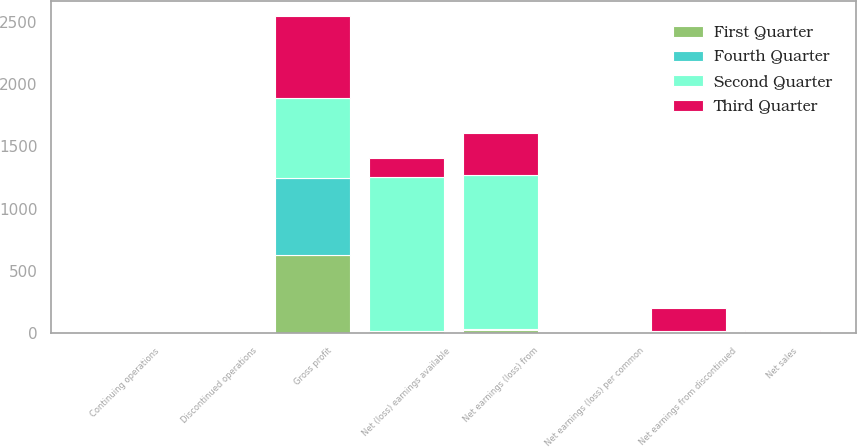Convert chart. <chart><loc_0><loc_0><loc_500><loc_500><stacked_bar_chart><ecel><fcel>Net sales<fcel>Gross profit<fcel>Net earnings (loss) from<fcel>Net earnings from discontinued<fcel>Net (loss) earnings available<fcel>Continuing operations<fcel>Discontinued operations<fcel>Net earnings (loss) per common<nl><fcel>Fourth Quarter<fcel>6.395<fcel>621.1<fcel>8.4<fcel>2.4<fcel>6<fcel>0.04<fcel>0.01<fcel>0.03<nl><fcel>First Quarter<fcel>6.395<fcel>628.3<fcel>20.7<fcel>7<fcel>13.7<fcel>0.11<fcel>0.04<fcel>0.07<nl><fcel>Second Quarter<fcel>6.395<fcel>643.6<fcel>1238.3<fcel>5.9<fcel>1232.4<fcel>6.41<fcel>0.03<fcel>6.38<nl><fcel>Third Quarter<fcel>6.395<fcel>651.3<fcel>342.7<fcel>184.5<fcel>158.2<fcel>1.78<fcel>0.95<fcel>0.83<nl></chart> 